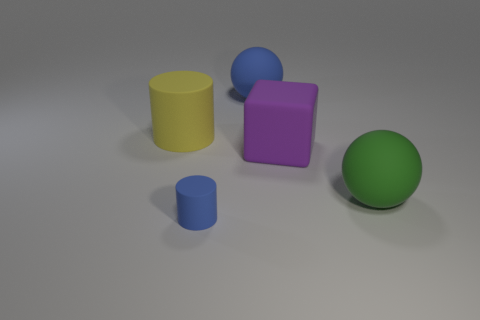Are there any other things that have the same size as the blue cylinder?
Your answer should be compact. No. Is the number of large purple blocks that are to the left of the tiny blue rubber cylinder greater than the number of purple blocks to the left of the yellow rubber cylinder?
Provide a succinct answer. No. What is the size of the cylinder that is the same material as the large yellow object?
Provide a succinct answer. Small. How big is the matte thing behind the yellow rubber thing that is in front of the blue matte object behind the small matte thing?
Your answer should be very brief. Large. There is a sphere left of the green thing; what color is it?
Your response must be concise. Blue. Are there more big yellow matte things that are to the left of the tiny matte object than big gray matte spheres?
Offer a very short reply. Yes. Does the large rubber thing that is to the left of the blue cylinder have the same shape as the tiny blue matte thing?
Offer a terse response. Yes. What number of green objects are large spheres or tiny matte things?
Offer a very short reply. 1. Is the number of blue rubber objects greater than the number of yellow cubes?
Keep it short and to the point. Yes. What color is the rubber cylinder that is the same size as the matte cube?
Give a very brief answer. Yellow. 